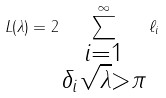<formula> <loc_0><loc_0><loc_500><loc_500>L ( \lambda ) = 2 \sum _ { \substack { i = 1 \\ \delta _ { i } \sqrt { \lambda } > \pi } } ^ { \infty } \ell _ { i }</formula> 